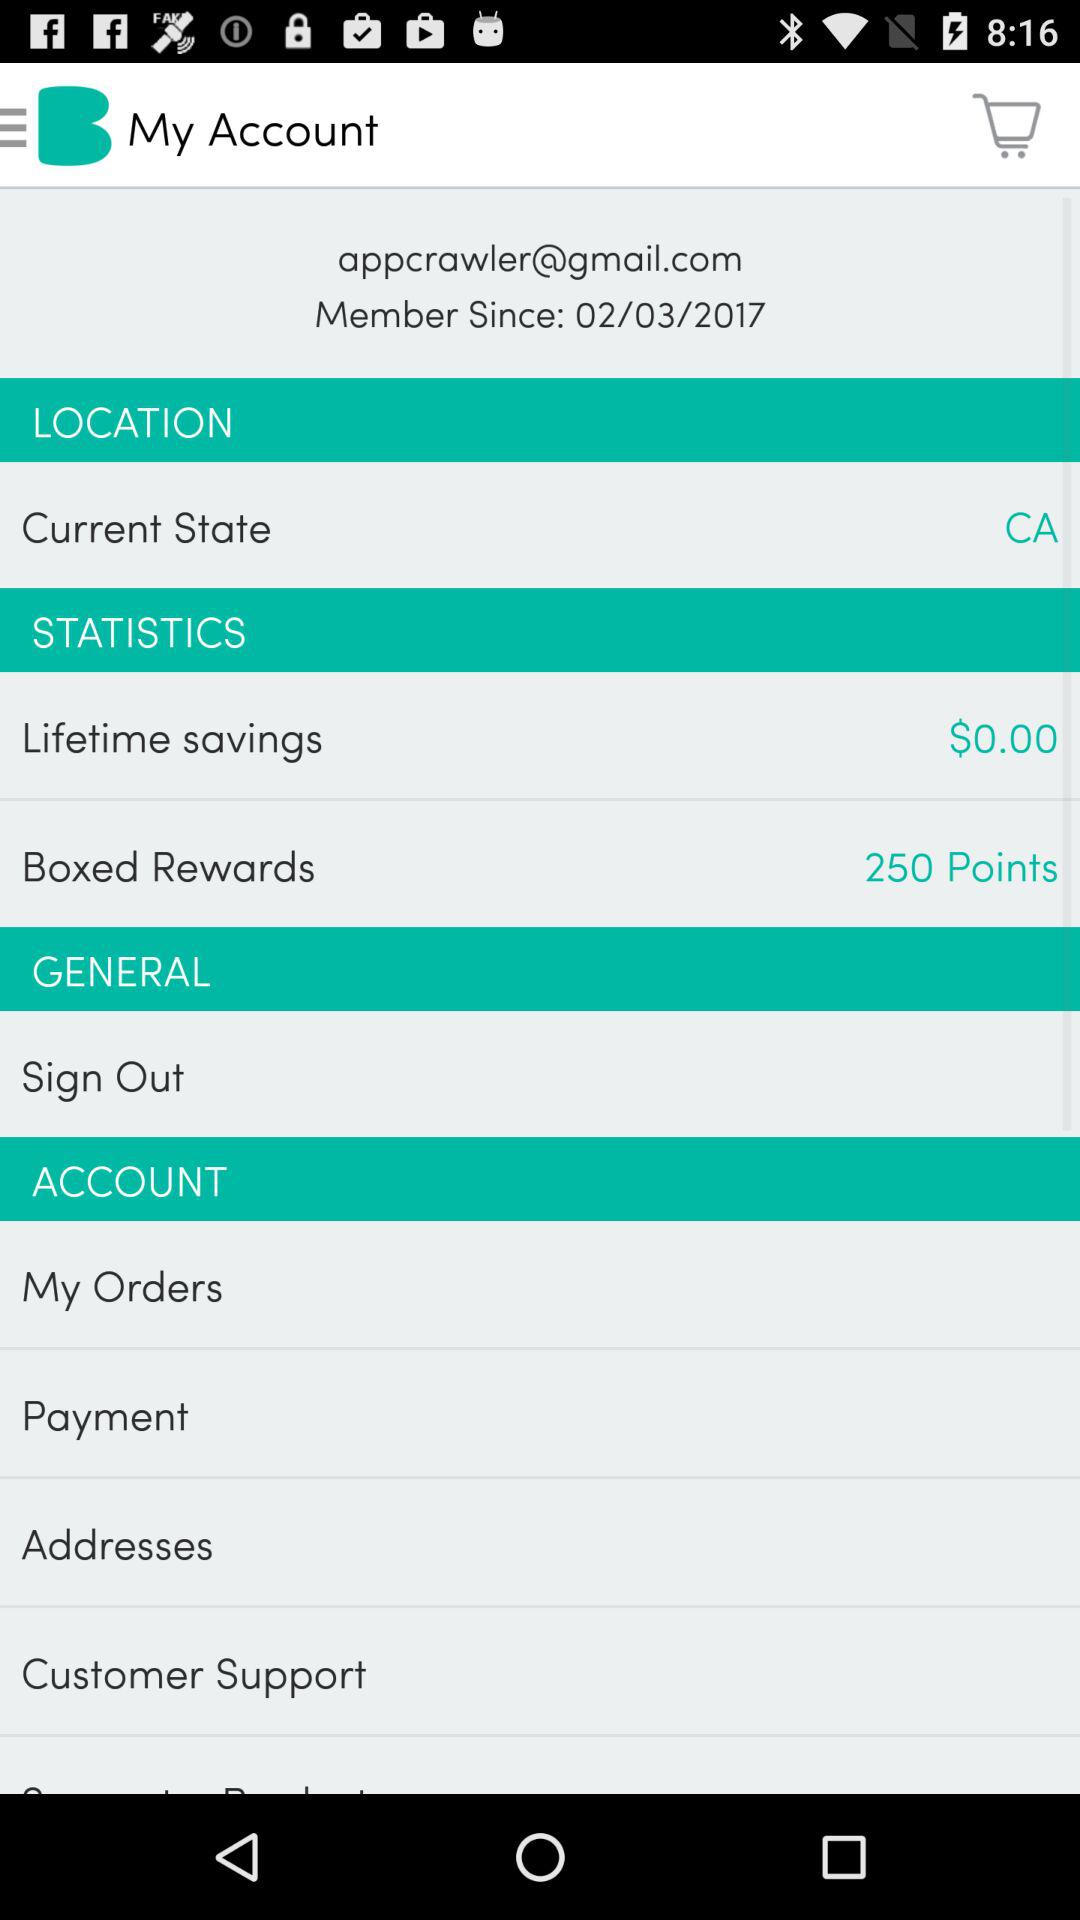How many Boxed Rewards points are there? There are 250 Boxed Rewards points. 